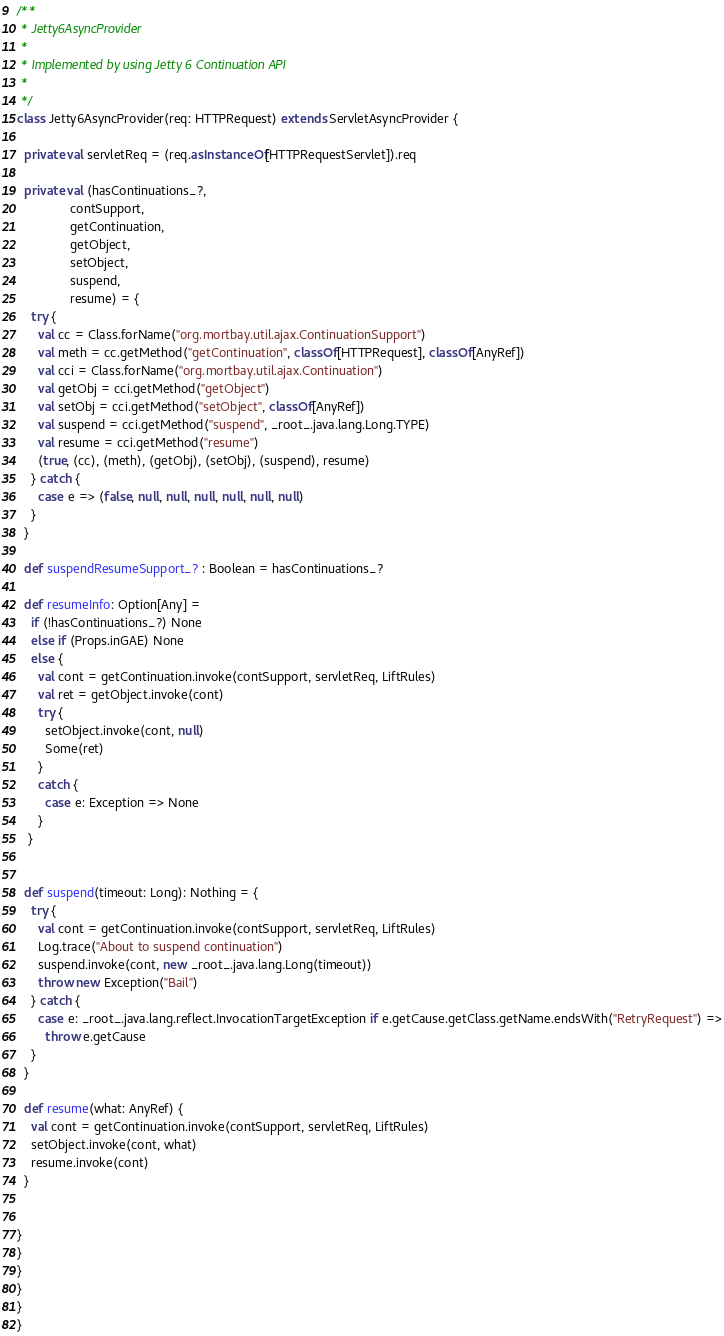Convert code to text. <code><loc_0><loc_0><loc_500><loc_500><_Scala_>
/**
 * Jetty6AsyncProvider
 *
 * Implemented by using Jetty 6 Continuation API
 *
 */
class Jetty6AsyncProvider(req: HTTPRequest) extends ServletAsyncProvider {

  private val servletReq = (req.asInstanceOf[HTTPRequestServlet]).req

  private val (hasContinuations_?,
               contSupport,
               getContinuation,
               getObject,
               setObject,
               suspend,
               resume) = {
    try {
      val cc = Class.forName("org.mortbay.util.ajax.ContinuationSupport")
      val meth = cc.getMethod("getContinuation", classOf[HTTPRequest], classOf[AnyRef])
      val cci = Class.forName("org.mortbay.util.ajax.Continuation")
      val getObj = cci.getMethod("getObject")
      val setObj = cci.getMethod("setObject", classOf[AnyRef])
      val suspend = cci.getMethod("suspend", _root_.java.lang.Long.TYPE)
      val resume = cci.getMethod("resume")
      (true, (cc), (meth), (getObj), (setObj), (suspend), resume)
    } catch {
      case e => (false, null, null, null, null, null, null)
    }
  }

  def suspendResumeSupport_? : Boolean = hasContinuations_?

  def resumeInfo: Option[Any] =
    if (!hasContinuations_?) None
    else if (Props.inGAE) None
    else {
      val cont = getContinuation.invoke(contSupport, servletReq, LiftRules)
      val ret = getObject.invoke(cont)
      try {
        setObject.invoke(cont, null)
        Some(ret)
      }
      catch {
        case e: Exception => None
      }
   }


  def suspend(timeout: Long): Nothing = {
    try {
      val cont = getContinuation.invoke(contSupport, servletReq, LiftRules)
      Log.trace("About to suspend continuation")
      suspend.invoke(cont, new _root_.java.lang.Long(timeout))
      throw new Exception("Bail")
    } catch {
      case e: _root_.java.lang.reflect.InvocationTargetException if e.getCause.getClass.getName.endsWith("RetryRequest") =>
        throw e.getCause
    }
  }

  def resume(what: AnyRef) {
    val cont = getContinuation.invoke(contSupport, servletReq, LiftRules)
    setObject.invoke(cont, what)
    resume.invoke(cont)
  }


}
}
}
}
}
}
</code> 